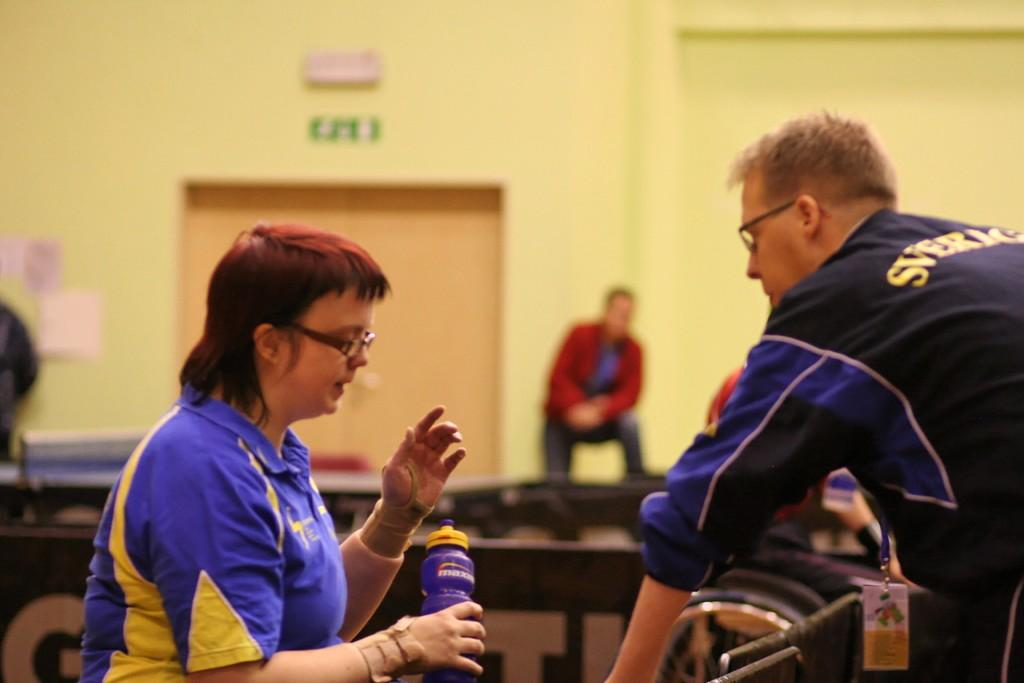How many people are present in the image? There are two people, a man and a woman, present in the image. What are the man and woman doing in the image? Both the man and woman are standing on the floor. What can be seen in the background of the image? There are persons in the background of the image, as well as a door and a wall. What type of wound can be seen on the writer in the image? There is no writer present in the image, nor is there any mention of a wound. 